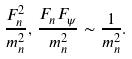<formula> <loc_0><loc_0><loc_500><loc_500>\frac { F _ { n } ^ { 2 } } { m _ { n } ^ { 2 } } , \, \frac { F _ { n } F _ { \psi } } { m _ { n } ^ { 2 } } \sim \frac { 1 } { m _ { n } ^ { 2 } } .</formula> 